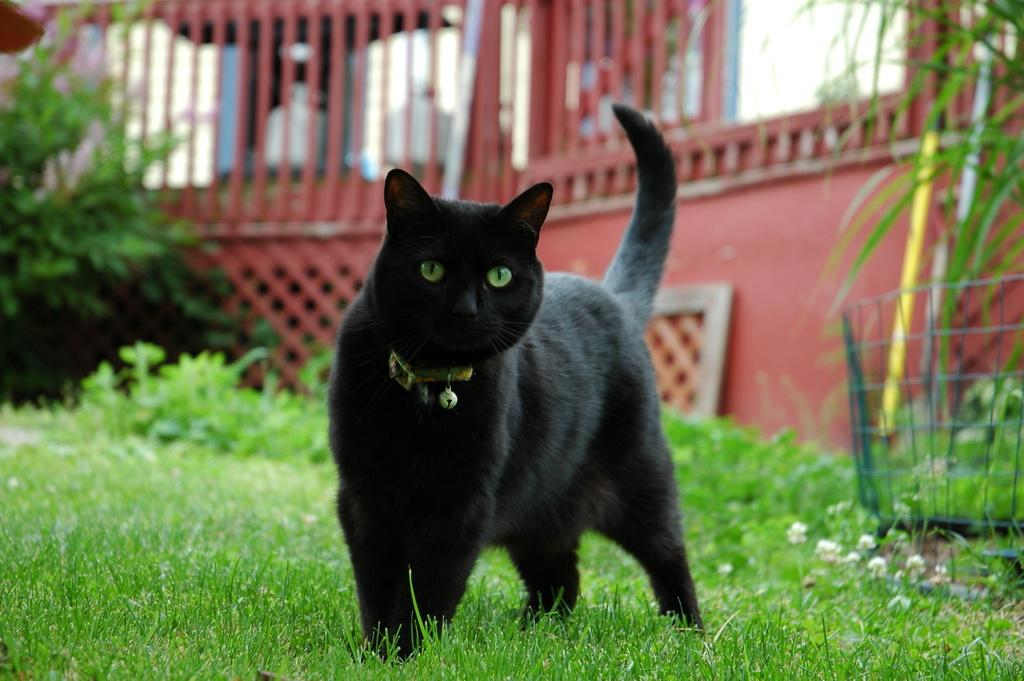What is the main subject in the image? There is a black (person or animal) standing on the grass. Can you describe the background of the image? The background of the image is blurred, but there is a wall, plants, a grill, and some unspecified objects visible. What is the subject standing on? The subject is standing on the grass. What might be the purpose of the grill in the background? The grill in the background might be used for cooking or barbecuing. How does the subject stretch in the image? There is no indication that the subject is stretching in the image; it is simply standing on the grass. What part of the subject is laughing in the image? There is no indication that the subject is laughing in the image; it is not displaying any facial expressions. 